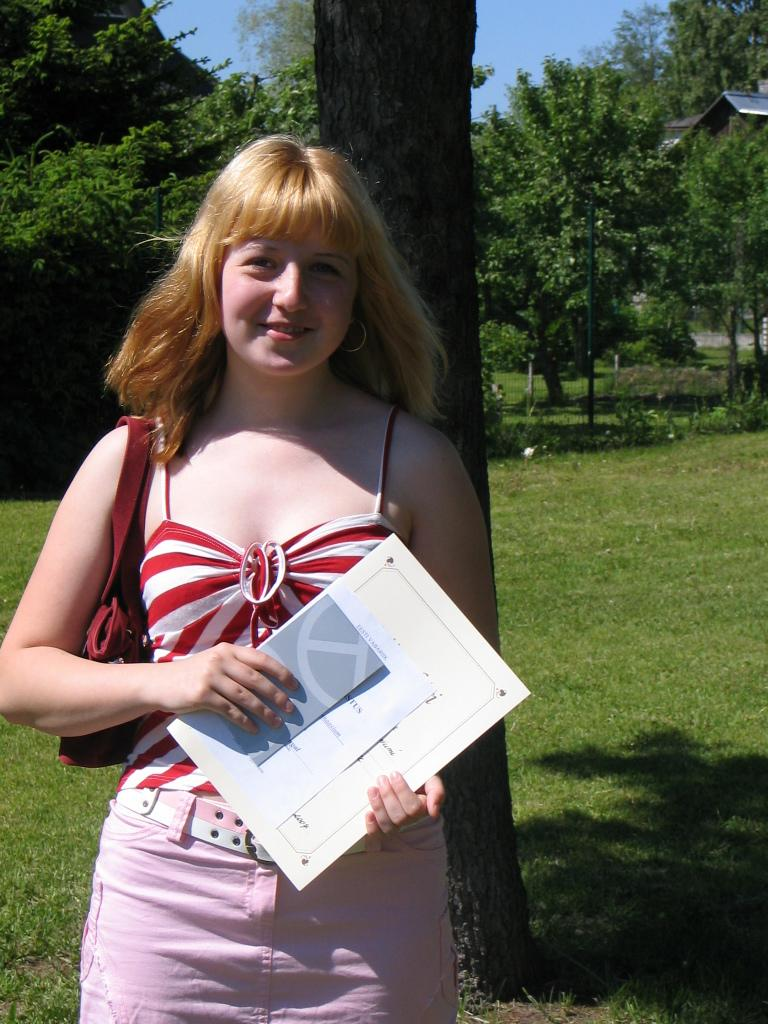Who is present in the image? There is a woman in the image. What is a distinctive feature of the woman's appearance? The woman has golden hair. What is the woman wearing? The woman is wearing a red vest. Where is the woman standing in the image? The woman is standing in front of a tree. What is the woman holding in the image? The woman is holding a book. What type of environment is depicted in the image? The scene is set on grassland. What can be seen in the background of the image? There are trees in the background of the image. What type of shoe is the woman wearing in the image? The provided facts do not mention any shoes worn by the woman in the image. 